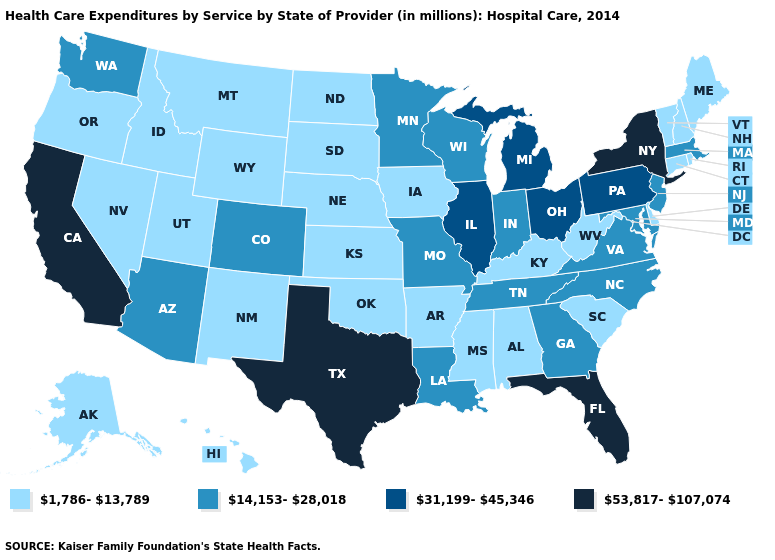What is the value of North Carolina?
Short answer required. 14,153-28,018. What is the highest value in the South ?
Answer briefly. 53,817-107,074. What is the highest value in the USA?
Quick response, please. 53,817-107,074. Name the states that have a value in the range 53,817-107,074?
Answer briefly. California, Florida, New York, Texas. Which states hav the highest value in the West?
Quick response, please. California. What is the value of Wyoming?
Answer briefly. 1,786-13,789. Does Indiana have the lowest value in the MidWest?
Write a very short answer. No. Does New York have the lowest value in the Northeast?
Write a very short answer. No. Name the states that have a value in the range 1,786-13,789?
Short answer required. Alabama, Alaska, Arkansas, Connecticut, Delaware, Hawaii, Idaho, Iowa, Kansas, Kentucky, Maine, Mississippi, Montana, Nebraska, Nevada, New Hampshire, New Mexico, North Dakota, Oklahoma, Oregon, Rhode Island, South Carolina, South Dakota, Utah, Vermont, West Virginia, Wyoming. Among the states that border Delaware , does Maryland have the lowest value?
Quick response, please. Yes. What is the lowest value in states that border Delaware?
Concise answer only. 14,153-28,018. What is the lowest value in the USA?
Answer briefly. 1,786-13,789. What is the value of Utah?
Be succinct. 1,786-13,789. Among the states that border Maine , which have the highest value?
Write a very short answer. New Hampshire. What is the value of Connecticut?
Answer briefly. 1,786-13,789. 